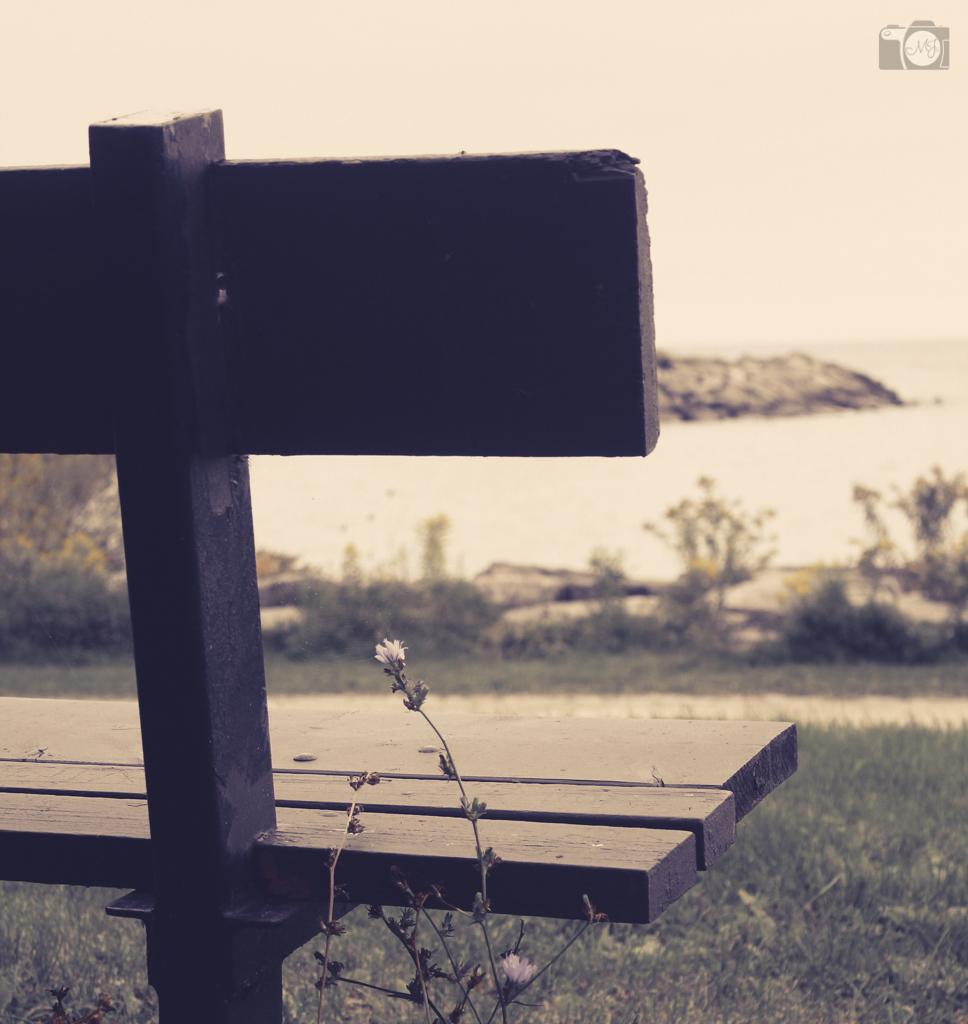What type of seating is visible in the image? There is a wooden bench in the image. What other elements can be seen in the image besides the bench? The image contains plants and grass. Is there any text or symbol present in the image? Yes, there is a logo at the top of the image. What type of teeth can be seen growing in the image? There are no teeth present in the image, and plants do not have teeth. 